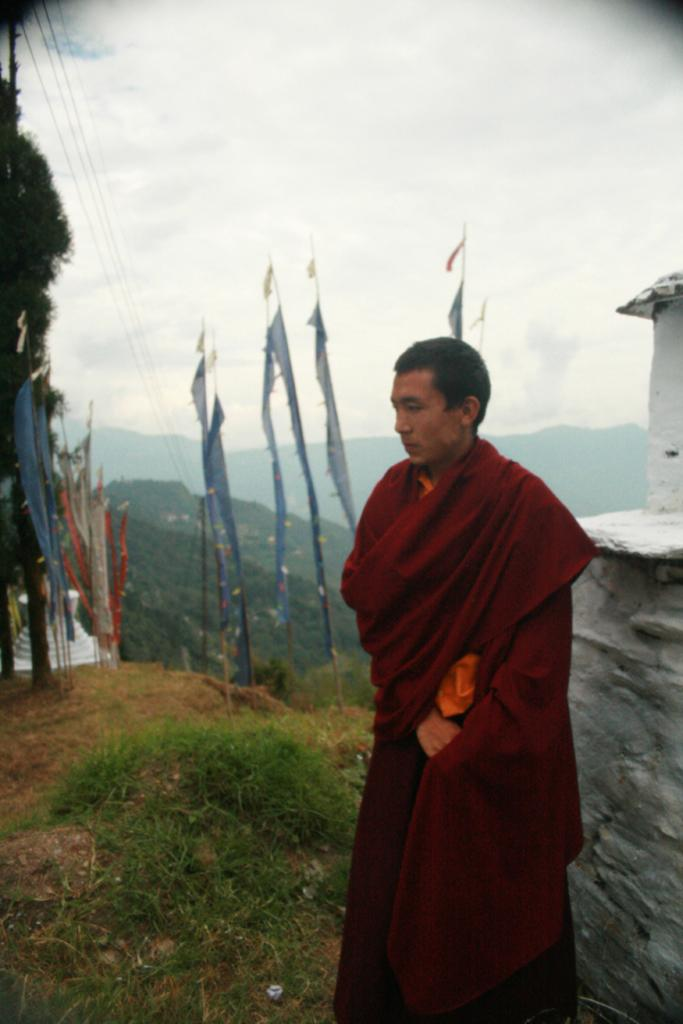What is the person in the image doing? The person is standing on the ground. Where is the person located in relation to other objects in the image? The person is near a wall. What can be seen in the image in the image besides the person and the wall? There are flags, trees, mountains, wires, and the sky visible in the image. What is the weather like in the image? The sky is visible with clouds present, suggesting a partly cloudy day. What type of comb is being used to style the person's hair in the image? There is no comb visible in the image, and it is not mentioned that the person's hair is being styled. 